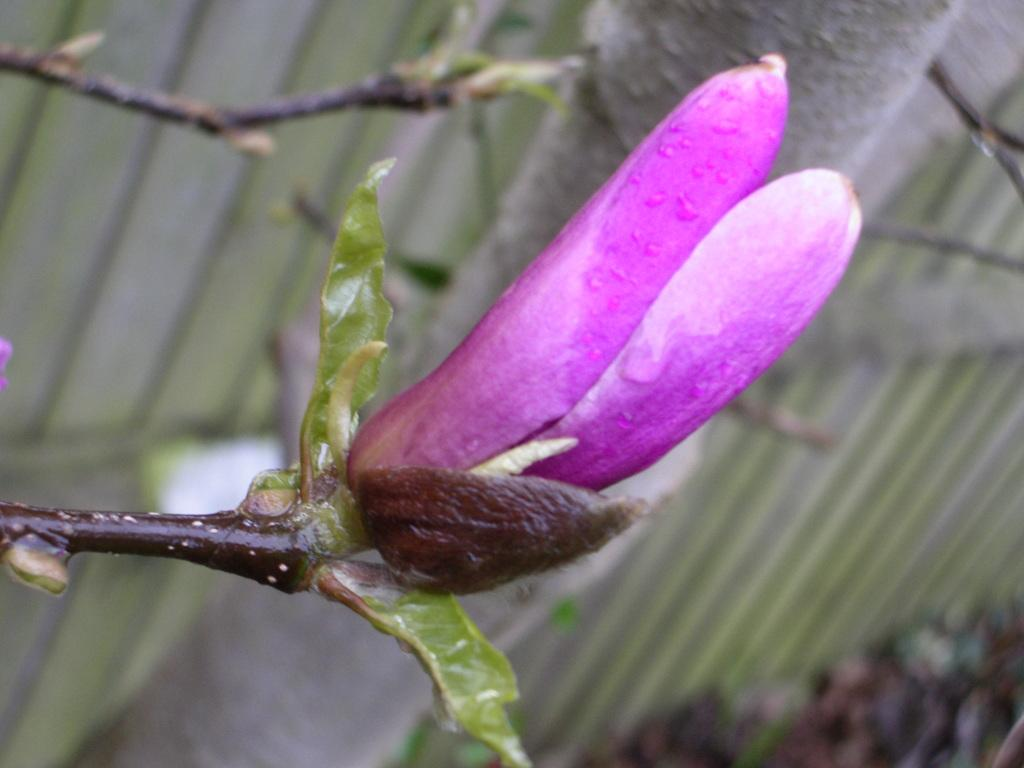What type of flower is in the image? There is a bud flower in the image. What colors can be seen on the flower? The flower is purple and white in color. What part of the flower is visible in the image? The stem of the flower is visible in the image. How would you describe the background of the image? The background of the image is blurred. How many dolls are holding yarn in the image? There are no dolls or yarn present in the image; it features a bud flower with a blurred background. 